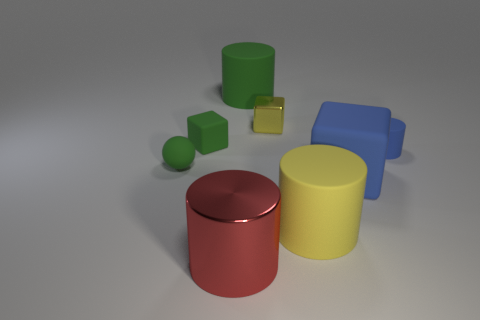What number of other objects are there of the same size as the metal cube?
Ensure brevity in your answer.  3. What number of things are either big cylinders on the left side of the yellow rubber cylinder or blue shiny cylinders?
Keep it short and to the point. 2. Are there an equal number of blue matte things that are behind the large blue matte block and small rubber objects to the right of the small ball?
Provide a succinct answer. No. What material is the yellow object that is behind the tiny object that is right of the yellow cylinder that is in front of the blue matte block?
Your response must be concise. Metal. How big is the cube that is both left of the yellow cylinder and right of the big red shiny object?
Your response must be concise. Small. Do the big red object and the yellow metal object have the same shape?
Offer a very short reply. No. What is the shape of the small blue object that is made of the same material as the big green object?
Your answer should be compact. Cylinder. How many small objects are blue matte blocks or red metal spheres?
Provide a short and direct response. 0. Is there a cube that is on the left side of the cube that is left of the red thing?
Your answer should be very brief. No. Are any small cyan metallic cylinders visible?
Give a very brief answer. No. 